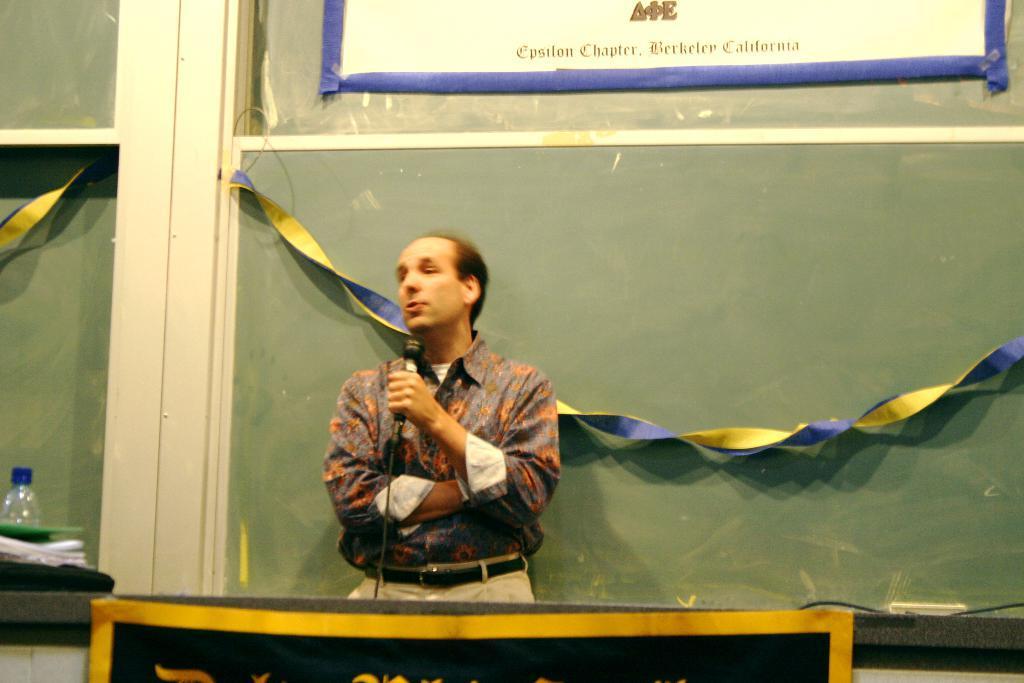Please provide a concise description of this image. In this image there is one person standing in middle of this image and holding a Mic , There is a table in the bottom of this image and there is a wall in the background. there is a white color paper attached on the wall as we can see on the top of this image. There is one bottle kept on the left side of this image. 